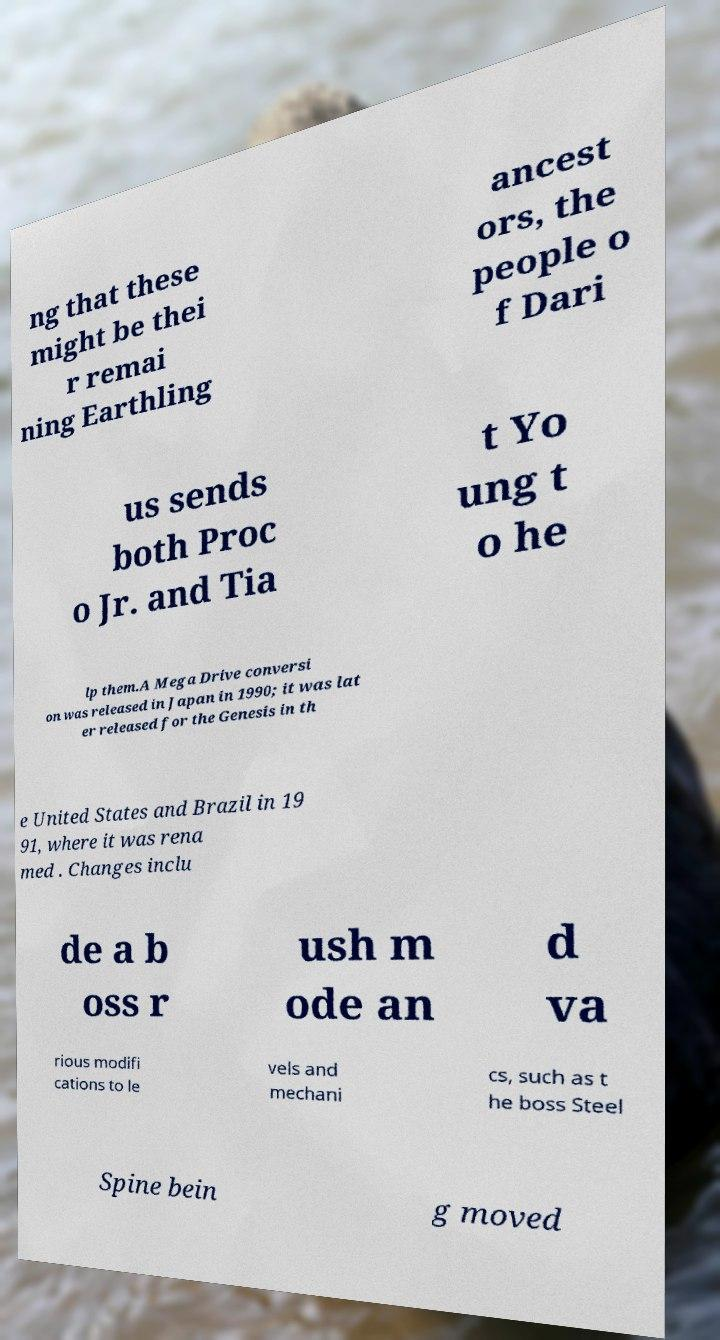What messages or text are displayed in this image? I need them in a readable, typed format. ng that these might be thei r remai ning Earthling ancest ors, the people o f Dari us sends both Proc o Jr. and Tia t Yo ung t o he lp them.A Mega Drive conversi on was released in Japan in 1990; it was lat er released for the Genesis in th e United States and Brazil in 19 91, where it was rena med . Changes inclu de a b oss r ush m ode an d va rious modifi cations to le vels and mechani cs, such as t he boss Steel Spine bein g moved 